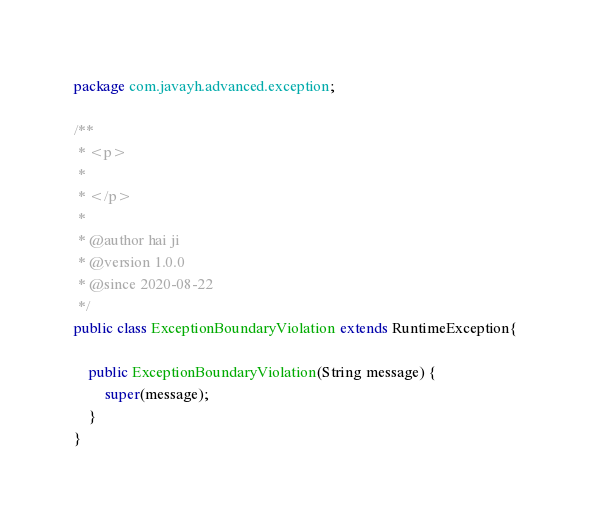Convert code to text. <code><loc_0><loc_0><loc_500><loc_500><_Java_>package com.javayh.advanced.exception;

/**
 * <p>
 *
 * </p>
 *
 * @author hai ji
 * @version 1.0.0
 * @since 2020-08-22
 */
public class ExceptionBoundaryViolation extends RuntimeException{

    public ExceptionBoundaryViolation(String message) {
        super(message);
    }
}
</code> 